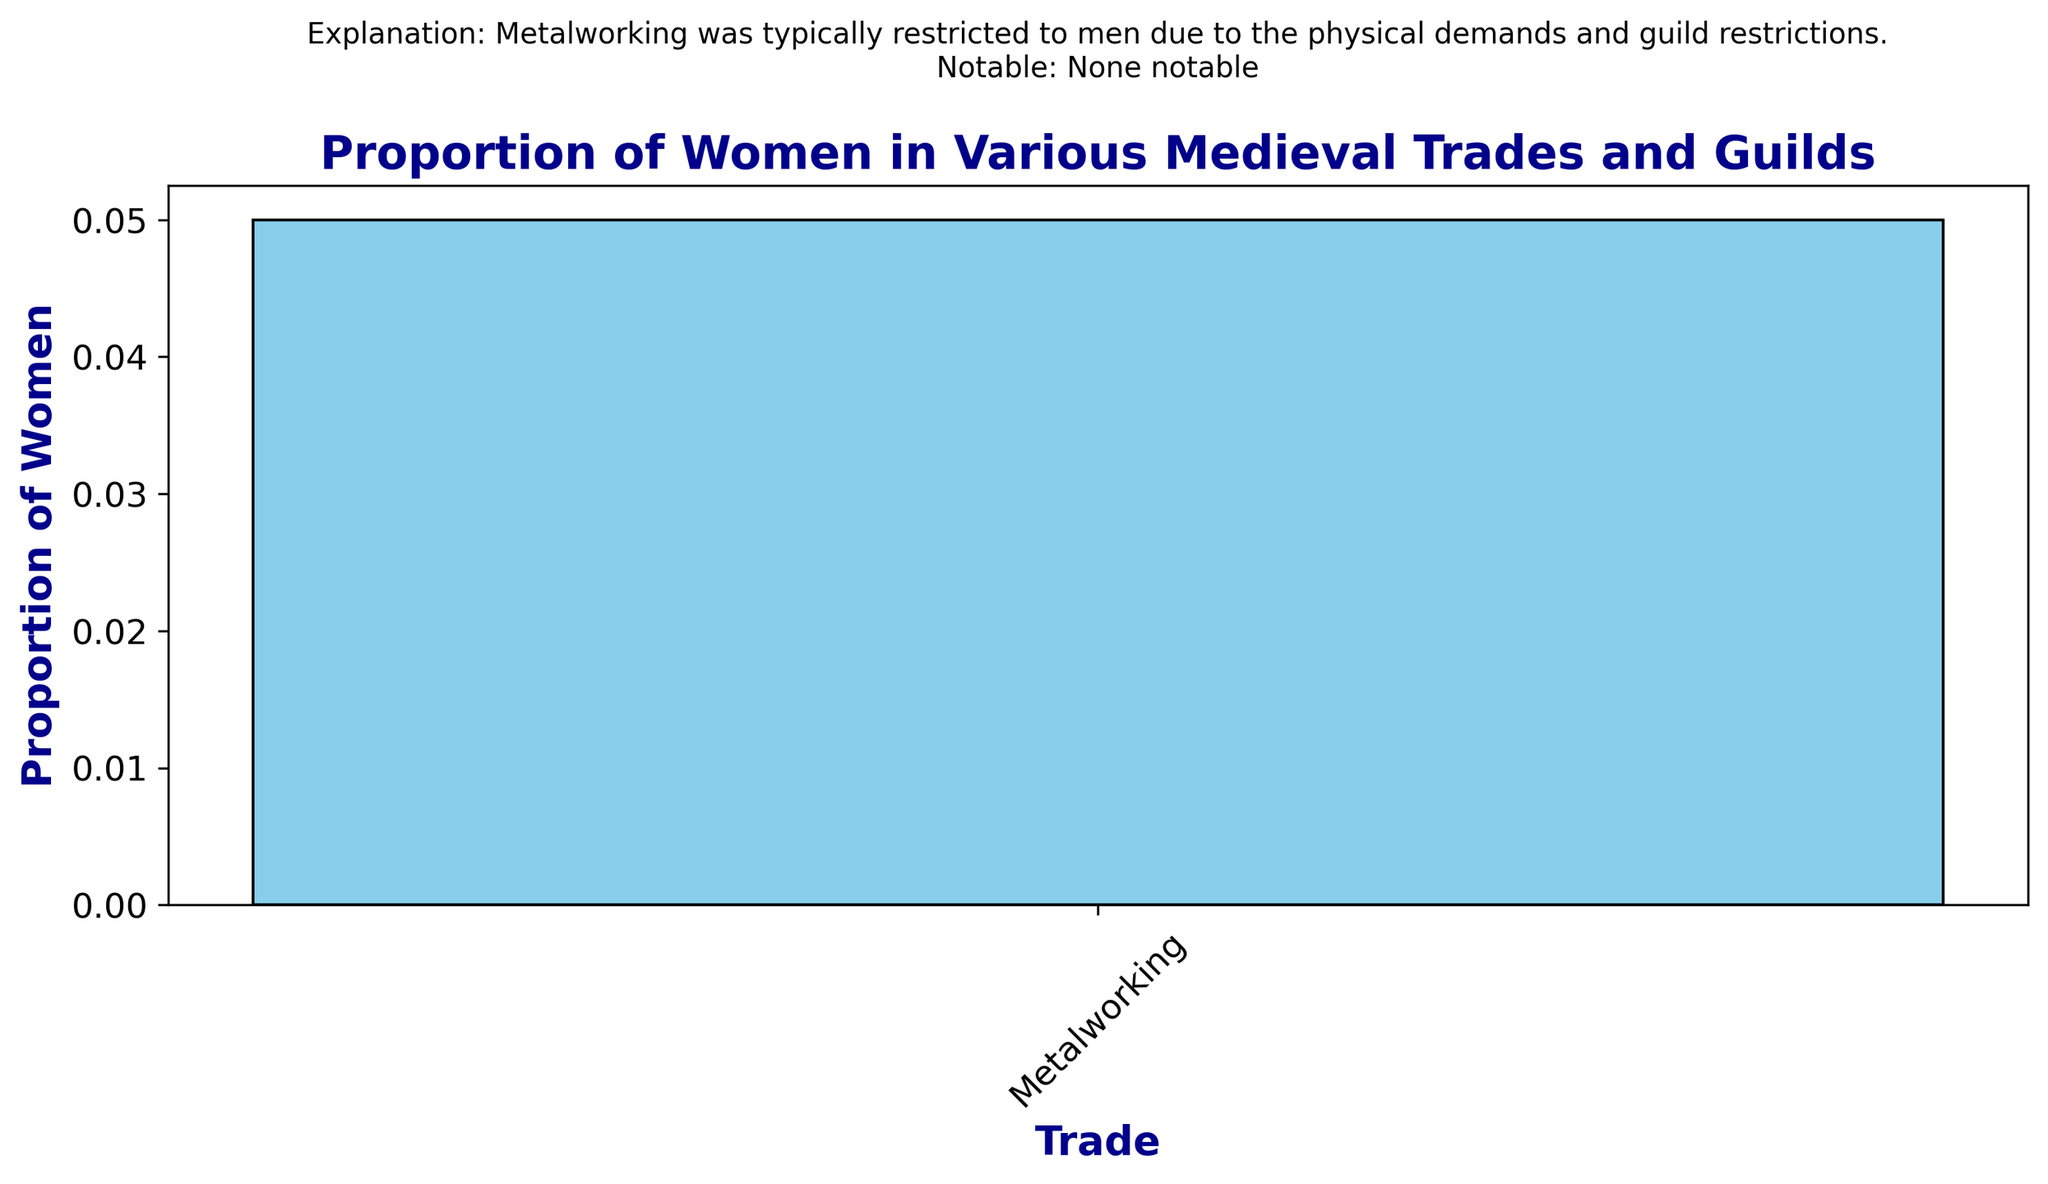What is the proportion of women in the metalworking trade? The bar chart shows the proportion of women in various trades. The metalworking trade has a bar reaching the 0.05 mark on the y-axis, indicating the proportion.
Answer: 0.05 What explanation is given for the proportion of women in metalworking? Above the metalworking bar, there is a text annotation. It states that metalworking was restricted to men due to physical demands and guild restrictions.
Answer: Metalworking was typically restricted to men due to the physical demands and guild restrictions Are there any notable female guild masters in metalworking? The annotation above the metalworking bar lists notable female guild masters. For metalworking, it states "None notable".
Answer: None notable Which trade has the highest proportion of women? Since there's only one bar (metalworking) in the figure, it has the highest proportion of women by default, though it is low (0.05).
Answer: Metalworking What are the barriers to women entering the metalworking trade? The annotation above the metalworking bar provides reasons for the low proportion of women. It mentions physical demands and guild restrictions as barriers.
Answer: Physical demands and guild restrictions 